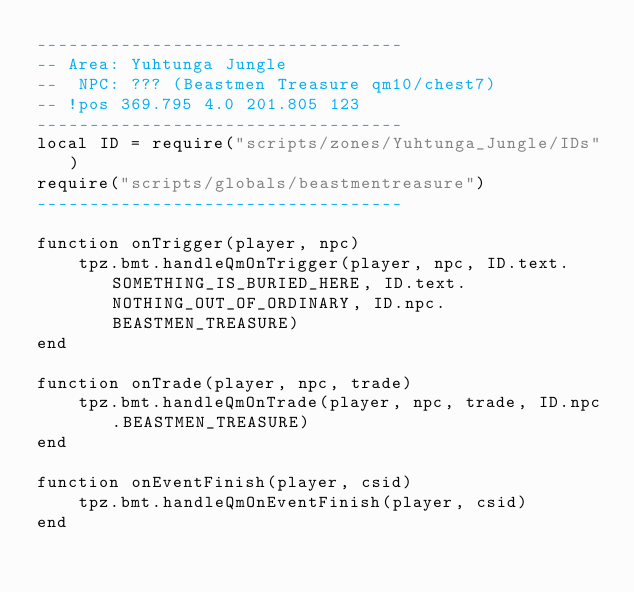Convert code to text. <code><loc_0><loc_0><loc_500><loc_500><_Lua_>-----------------------------------
-- Area: Yuhtunga Jungle
--  NPC: ??? (Beastmen Treasure qm10/chest7)
-- !pos 369.795 4.0 201.805 123
-----------------------------------
local ID = require("scripts/zones/Yuhtunga_Jungle/IDs")
require("scripts/globals/beastmentreasure")
-----------------------------------

function onTrigger(player, npc)
    tpz.bmt.handleQmOnTrigger(player, npc, ID.text.SOMETHING_IS_BURIED_HERE, ID.text.NOTHING_OUT_OF_ORDINARY, ID.npc.BEASTMEN_TREASURE)
end

function onTrade(player, npc, trade)
    tpz.bmt.handleQmOnTrade(player, npc, trade, ID.npc.BEASTMEN_TREASURE)
end

function onEventFinish(player, csid)
    tpz.bmt.handleQmOnEventFinish(player, csid)
end
</code> 